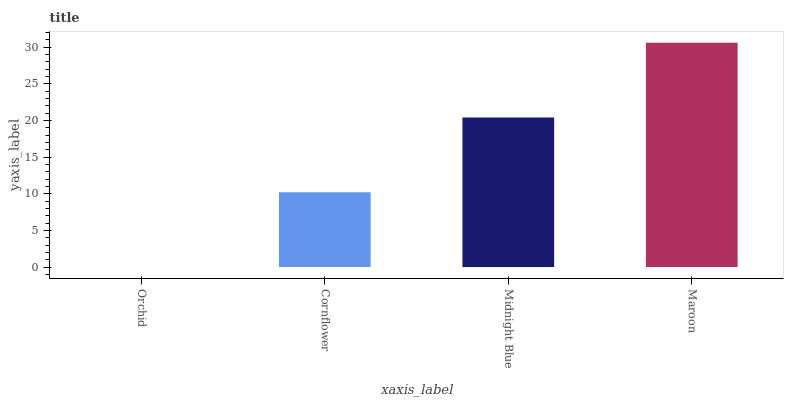Is Cornflower the minimum?
Answer yes or no. No. Is Cornflower the maximum?
Answer yes or no. No. Is Cornflower greater than Orchid?
Answer yes or no. Yes. Is Orchid less than Cornflower?
Answer yes or no. Yes. Is Orchid greater than Cornflower?
Answer yes or no. No. Is Cornflower less than Orchid?
Answer yes or no. No. Is Midnight Blue the high median?
Answer yes or no. Yes. Is Cornflower the low median?
Answer yes or no. Yes. Is Cornflower the high median?
Answer yes or no. No. Is Orchid the low median?
Answer yes or no. No. 